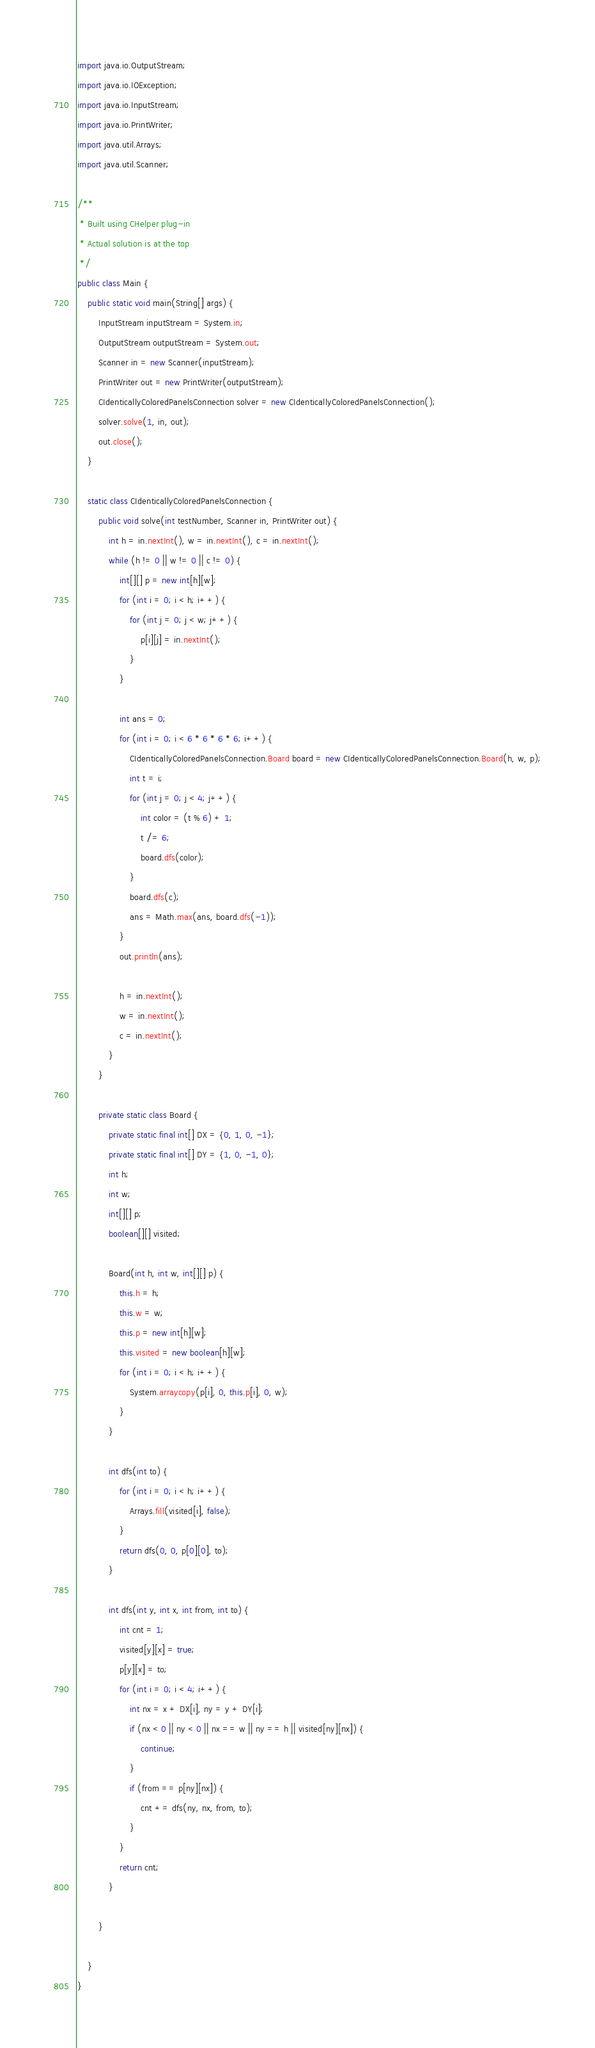<code> <loc_0><loc_0><loc_500><loc_500><_Java_>import java.io.OutputStream;
import java.io.IOException;
import java.io.InputStream;
import java.io.PrintWriter;
import java.util.Arrays;
import java.util.Scanner;

/**
 * Built using CHelper plug-in
 * Actual solution is at the top
 */
public class Main {
    public static void main(String[] args) {
        InputStream inputStream = System.in;
        OutputStream outputStream = System.out;
        Scanner in = new Scanner(inputStream);
        PrintWriter out = new PrintWriter(outputStream);
        CIdenticallyColoredPanelsConnection solver = new CIdenticallyColoredPanelsConnection();
        solver.solve(1, in, out);
        out.close();
    }

    static class CIdenticallyColoredPanelsConnection {
        public void solve(int testNumber, Scanner in, PrintWriter out) {
            int h = in.nextInt(), w = in.nextInt(), c = in.nextInt();
            while (h != 0 || w != 0 || c != 0) {
                int[][] p = new int[h][w];
                for (int i = 0; i < h; i++) {
                    for (int j = 0; j < w; j++) {
                        p[i][j] = in.nextInt();
                    }
                }

                int ans = 0;
                for (int i = 0; i < 6 * 6 * 6 * 6; i++) {
                    CIdenticallyColoredPanelsConnection.Board board = new CIdenticallyColoredPanelsConnection.Board(h, w, p);
                    int t = i;
                    for (int j = 0; j < 4; j++) {
                        int color = (t % 6) + 1;
                        t /= 6;
                        board.dfs(color);
                    }
                    board.dfs(c);
                    ans = Math.max(ans, board.dfs(-1));
                }
                out.println(ans);

                h = in.nextInt();
                w = in.nextInt();
                c = in.nextInt();
            }
        }

        private static class Board {
            private static final int[] DX = {0, 1, 0, -1};
            private static final int[] DY = {1, 0, -1, 0};
            int h;
            int w;
            int[][] p;
            boolean[][] visited;

            Board(int h, int w, int[][] p) {
                this.h = h;
                this.w = w;
                this.p = new int[h][w];
                this.visited = new boolean[h][w];
                for (int i = 0; i < h; i++) {
                    System.arraycopy(p[i], 0, this.p[i], 0, w);
                }
            }

            int dfs(int to) {
                for (int i = 0; i < h; i++) {
                    Arrays.fill(visited[i], false);
                }
                return dfs(0, 0, p[0][0], to);
            }

            int dfs(int y, int x, int from, int to) {
                int cnt = 1;
                visited[y][x] = true;
                p[y][x] = to;
                for (int i = 0; i < 4; i++) {
                    int nx = x + DX[i], ny = y + DY[i];
                    if (nx < 0 || ny < 0 || nx == w || ny == h || visited[ny][nx]) {
                        continue;
                    }
                    if (from == p[ny][nx]) {
                        cnt += dfs(ny, nx, from, to);
                    }
                }
                return cnt;
            }

        }

    }
}


</code> 